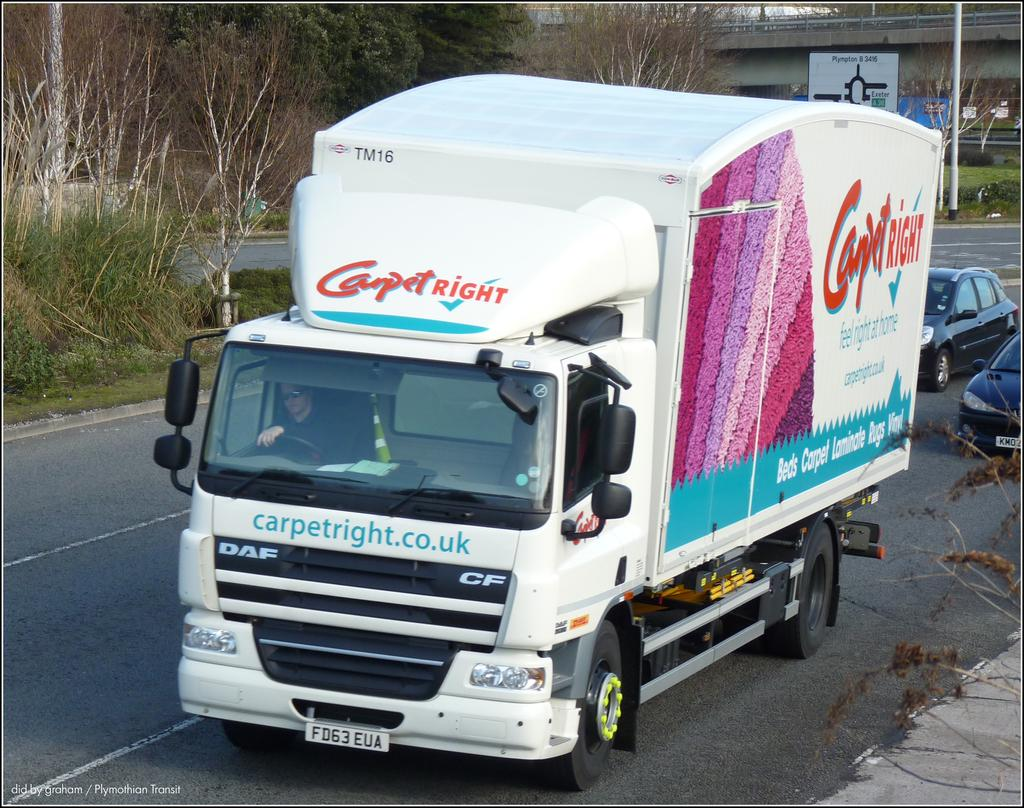What type of vehicle is on the road in the image? There is a truck on the road in the image. What else is moving on the road besides the truck? Two cars are moving on the road. What is located behind the road in the image? There is a bridge behind the road. What can be seen around the road in the image? There are plants around the road. What type of butter is being traded on the bridge in the image? There is no butter or trade activity present in the image. What wall is visible in the image? There is no wall visible in the image. 